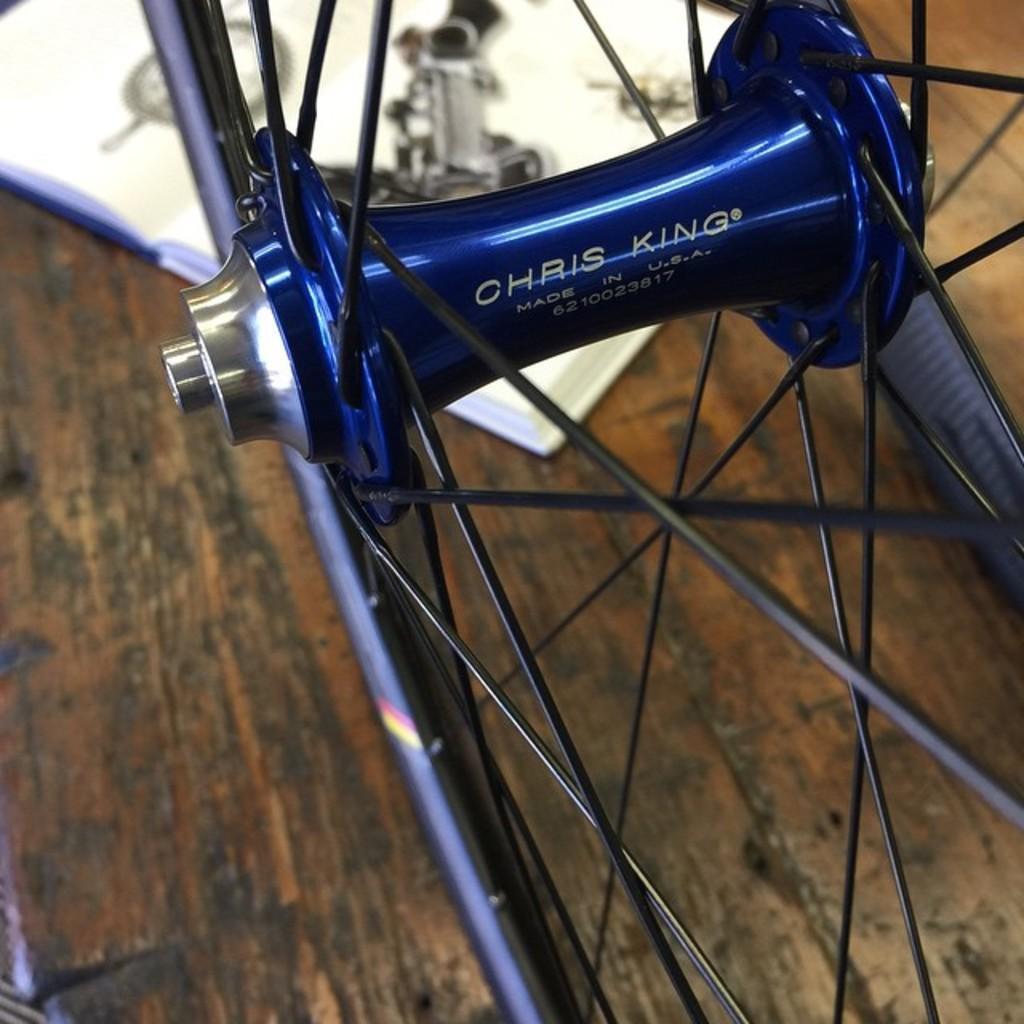How would you summarize this image in a sentence or two? In this image I can see a wheel which is blue and black in color on the brown and black colored surface. I can see a white colored object on the surface. 